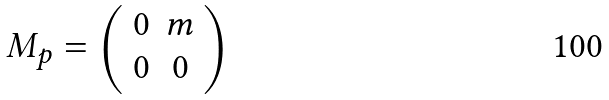Convert formula to latex. <formula><loc_0><loc_0><loc_500><loc_500>M _ { p } = \left ( \begin{array} { c c } 0 & m \\ 0 & 0 \end{array} \right )</formula> 